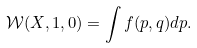Convert formula to latex. <formula><loc_0><loc_0><loc_500><loc_500>\mathcal { W } ( X , 1 , 0 ) = \int f ( p , q ) d p .</formula> 